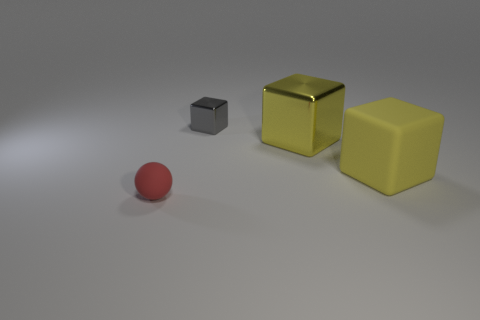The matte sphere is what size?
Your response must be concise. Small. Are there more large metallic blocks in front of the yellow rubber thing than big yellow rubber blocks?
Keep it short and to the point. No. How many big yellow shiny cubes are to the right of the small red ball?
Offer a very short reply. 1. Are there any other yellow objects of the same size as the yellow rubber thing?
Your answer should be very brief. Yes. There is another large thing that is the same shape as the yellow metallic thing; what is its color?
Provide a succinct answer. Yellow. Does the matte object that is to the right of the tiny rubber thing have the same size as the shiny object that is on the right side of the small shiny cube?
Offer a terse response. Yes. Is there a large cyan object that has the same shape as the red rubber object?
Your response must be concise. No. Are there an equal number of tiny red rubber balls that are left of the large shiny cube and large blocks?
Ensure brevity in your answer.  No. There is a gray metallic thing; does it have the same size as the object that is in front of the big rubber thing?
Your response must be concise. Yes. What number of other tiny objects have the same material as the small red object?
Provide a succinct answer. 0. 